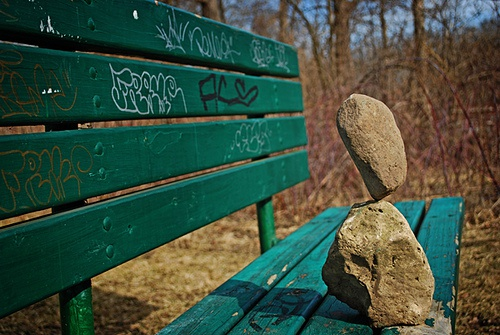Describe the objects in this image and their specific colors. I can see a bench in black, teal, darkgreen, and tan tones in this image. 